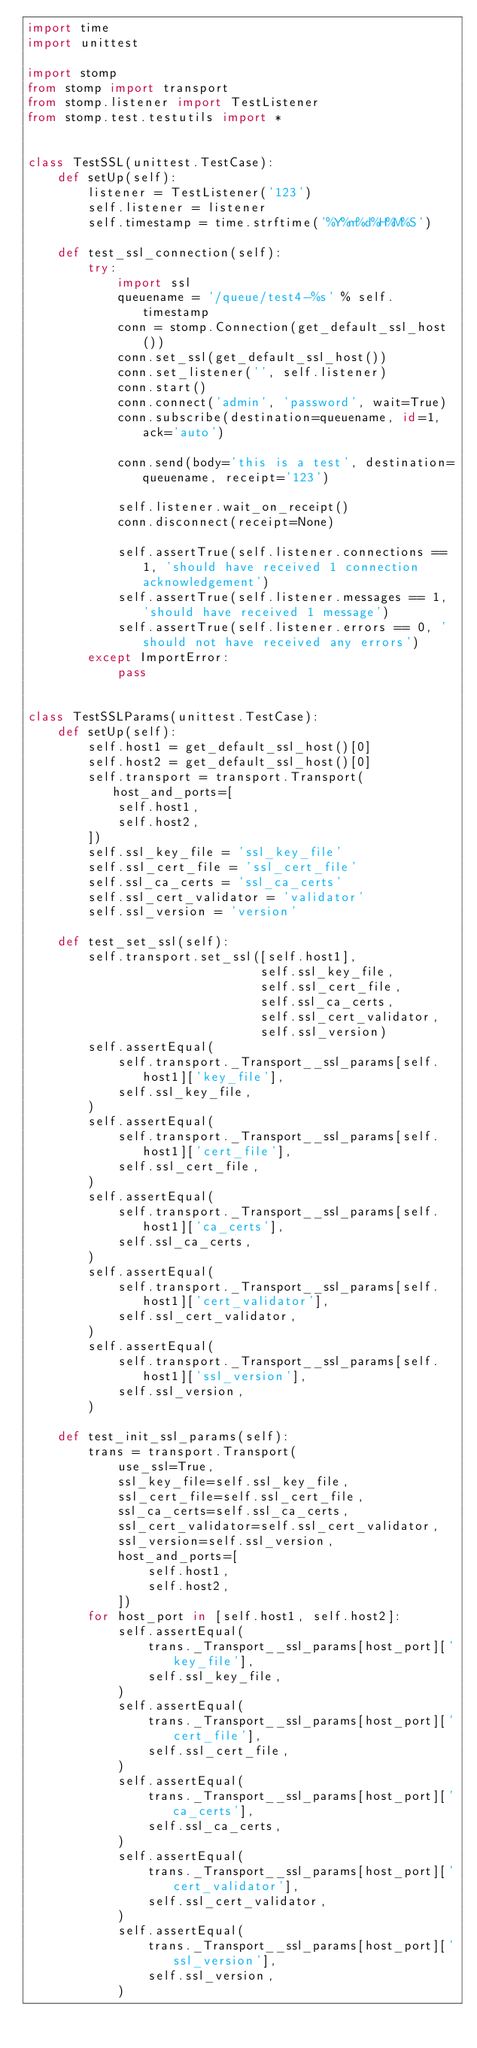<code> <loc_0><loc_0><loc_500><loc_500><_Python_>import time
import unittest

import stomp
from stomp import transport
from stomp.listener import TestListener
from stomp.test.testutils import *


class TestSSL(unittest.TestCase):
    def setUp(self):
        listener = TestListener('123')
        self.listener = listener
        self.timestamp = time.strftime('%Y%m%d%H%M%S')

    def test_ssl_connection(self):
        try:
            import ssl
            queuename = '/queue/test4-%s' % self.timestamp
            conn = stomp.Connection(get_default_ssl_host())
            conn.set_ssl(get_default_ssl_host())
            conn.set_listener('', self.listener)
            conn.start()
            conn.connect('admin', 'password', wait=True)
            conn.subscribe(destination=queuename, id=1, ack='auto')

            conn.send(body='this is a test', destination=queuename, receipt='123')

            self.listener.wait_on_receipt()
            conn.disconnect(receipt=None)

            self.assertTrue(self.listener.connections == 1, 'should have received 1 connection acknowledgement')
            self.assertTrue(self.listener.messages == 1, 'should have received 1 message')
            self.assertTrue(self.listener.errors == 0, 'should not have received any errors')
        except ImportError:
            pass


class TestSSLParams(unittest.TestCase):
    def setUp(self):
        self.host1 = get_default_ssl_host()[0]
        self.host2 = get_default_ssl_host()[0]
        self.transport = transport.Transport(host_and_ports=[
            self.host1,
            self.host2,
        ])
        self.ssl_key_file = 'ssl_key_file'
        self.ssl_cert_file = 'ssl_cert_file'
        self.ssl_ca_certs = 'ssl_ca_certs'
        self.ssl_cert_validator = 'validator'
        self.ssl_version = 'version'

    def test_set_ssl(self):
        self.transport.set_ssl([self.host1],
                               self.ssl_key_file,
                               self.ssl_cert_file,
                               self.ssl_ca_certs,
                               self.ssl_cert_validator,
                               self.ssl_version)
        self.assertEqual(
            self.transport._Transport__ssl_params[self.host1]['key_file'],
            self.ssl_key_file,
        )
        self.assertEqual(
            self.transport._Transport__ssl_params[self.host1]['cert_file'],
            self.ssl_cert_file,
        )
        self.assertEqual(
            self.transport._Transport__ssl_params[self.host1]['ca_certs'],
            self.ssl_ca_certs,
        )
        self.assertEqual(
            self.transport._Transport__ssl_params[self.host1]['cert_validator'],
            self.ssl_cert_validator,
        )
        self.assertEqual(
            self.transport._Transport__ssl_params[self.host1]['ssl_version'],
            self.ssl_version,
        )

    def test_init_ssl_params(self):
        trans = transport.Transport(
            use_ssl=True,
            ssl_key_file=self.ssl_key_file,
            ssl_cert_file=self.ssl_cert_file,
            ssl_ca_certs=self.ssl_ca_certs,
            ssl_cert_validator=self.ssl_cert_validator,
            ssl_version=self.ssl_version,
            host_and_ports=[
                self.host1,
                self.host2,
            ])
        for host_port in [self.host1, self.host2]:
            self.assertEqual(
                trans._Transport__ssl_params[host_port]['key_file'],
                self.ssl_key_file,
            )
            self.assertEqual(
                trans._Transport__ssl_params[host_port]['cert_file'],
                self.ssl_cert_file,
            )
            self.assertEqual(
                trans._Transport__ssl_params[host_port]['ca_certs'],
                self.ssl_ca_certs,
            )
            self.assertEqual(
                trans._Transport__ssl_params[host_port]['cert_validator'],
                self.ssl_cert_validator,
            )
            self.assertEqual(
                trans._Transport__ssl_params[host_port]['ssl_version'],
                self.ssl_version,
            )
</code> 